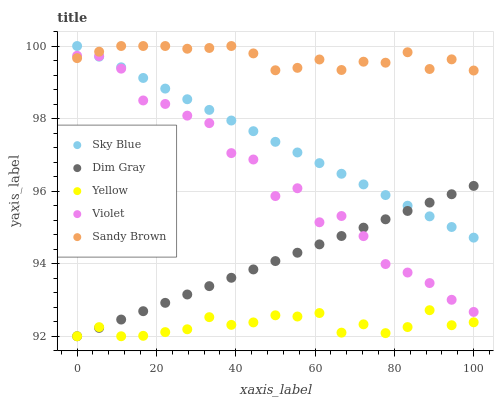Does Yellow have the minimum area under the curve?
Answer yes or no. Yes. Does Sandy Brown have the maximum area under the curve?
Answer yes or no. Yes. Does Dim Gray have the minimum area under the curve?
Answer yes or no. No. Does Dim Gray have the maximum area under the curve?
Answer yes or no. No. Is Sky Blue the smoothest?
Answer yes or no. Yes. Is Violet the roughest?
Answer yes or no. Yes. Is Dim Gray the smoothest?
Answer yes or no. No. Is Dim Gray the roughest?
Answer yes or no. No. Does Dim Gray have the lowest value?
Answer yes or no. Yes. Does Sandy Brown have the lowest value?
Answer yes or no. No. Does Sandy Brown have the highest value?
Answer yes or no. Yes. Does Dim Gray have the highest value?
Answer yes or no. No. Is Yellow less than Sky Blue?
Answer yes or no. Yes. Is Sky Blue greater than Yellow?
Answer yes or no. Yes. Does Sandy Brown intersect Sky Blue?
Answer yes or no. Yes. Is Sandy Brown less than Sky Blue?
Answer yes or no. No. Is Sandy Brown greater than Sky Blue?
Answer yes or no. No. Does Yellow intersect Sky Blue?
Answer yes or no. No. 